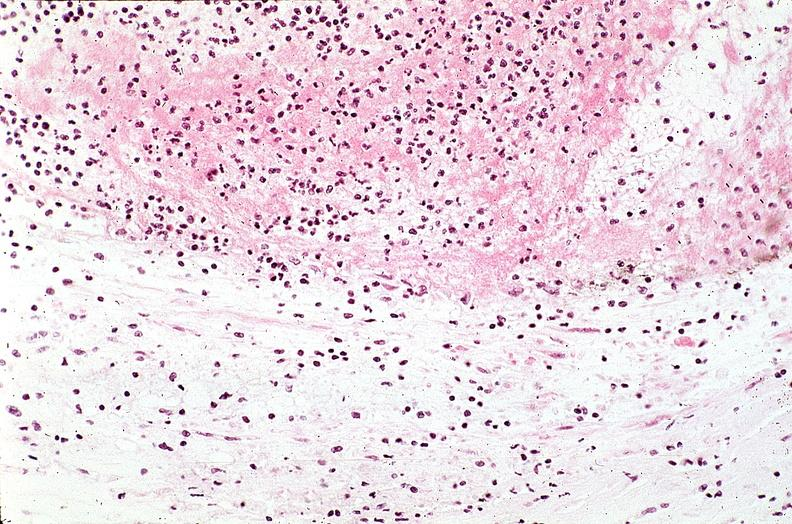where is this from?
Answer the question using a single word or phrase. Vasculature 